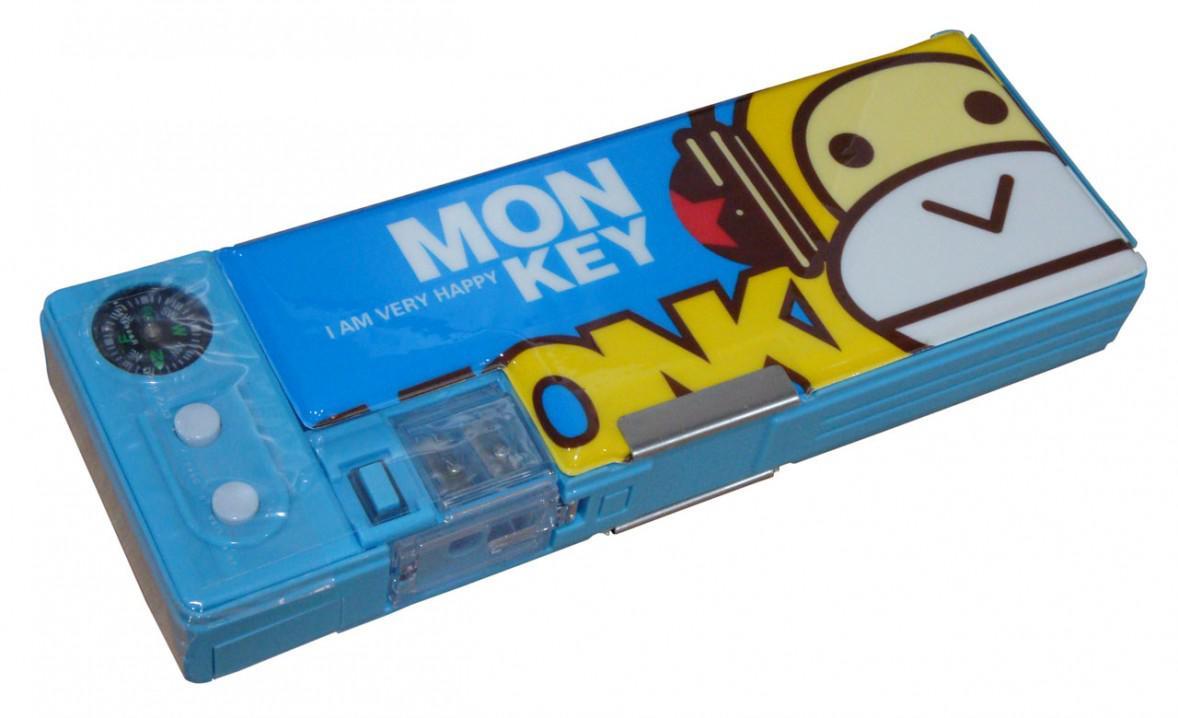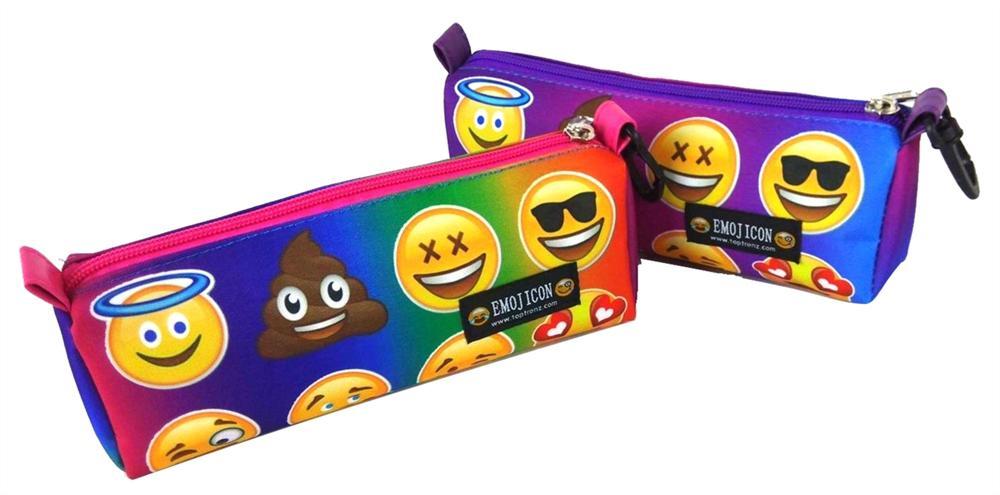The first image is the image on the left, the second image is the image on the right. Given the left and right images, does the statement "There are only two pencil cases, and both are closed." hold true? Answer yes or no. No. The first image is the image on the left, the second image is the image on the right. For the images shown, is this caption "Each image shows a single closed case, and all cases feature blue in their color scheme." true? Answer yes or no. No. The first image is the image on the left, the second image is the image on the right. For the images shown, is this caption "There are more pencil cases in the image on the right." true? Answer yes or no. Yes. The first image is the image on the left, the second image is the image on the right. Considering the images on both sides, is "Only two pencil cases are visible in the pair of images." valid? Answer yes or no. No. 